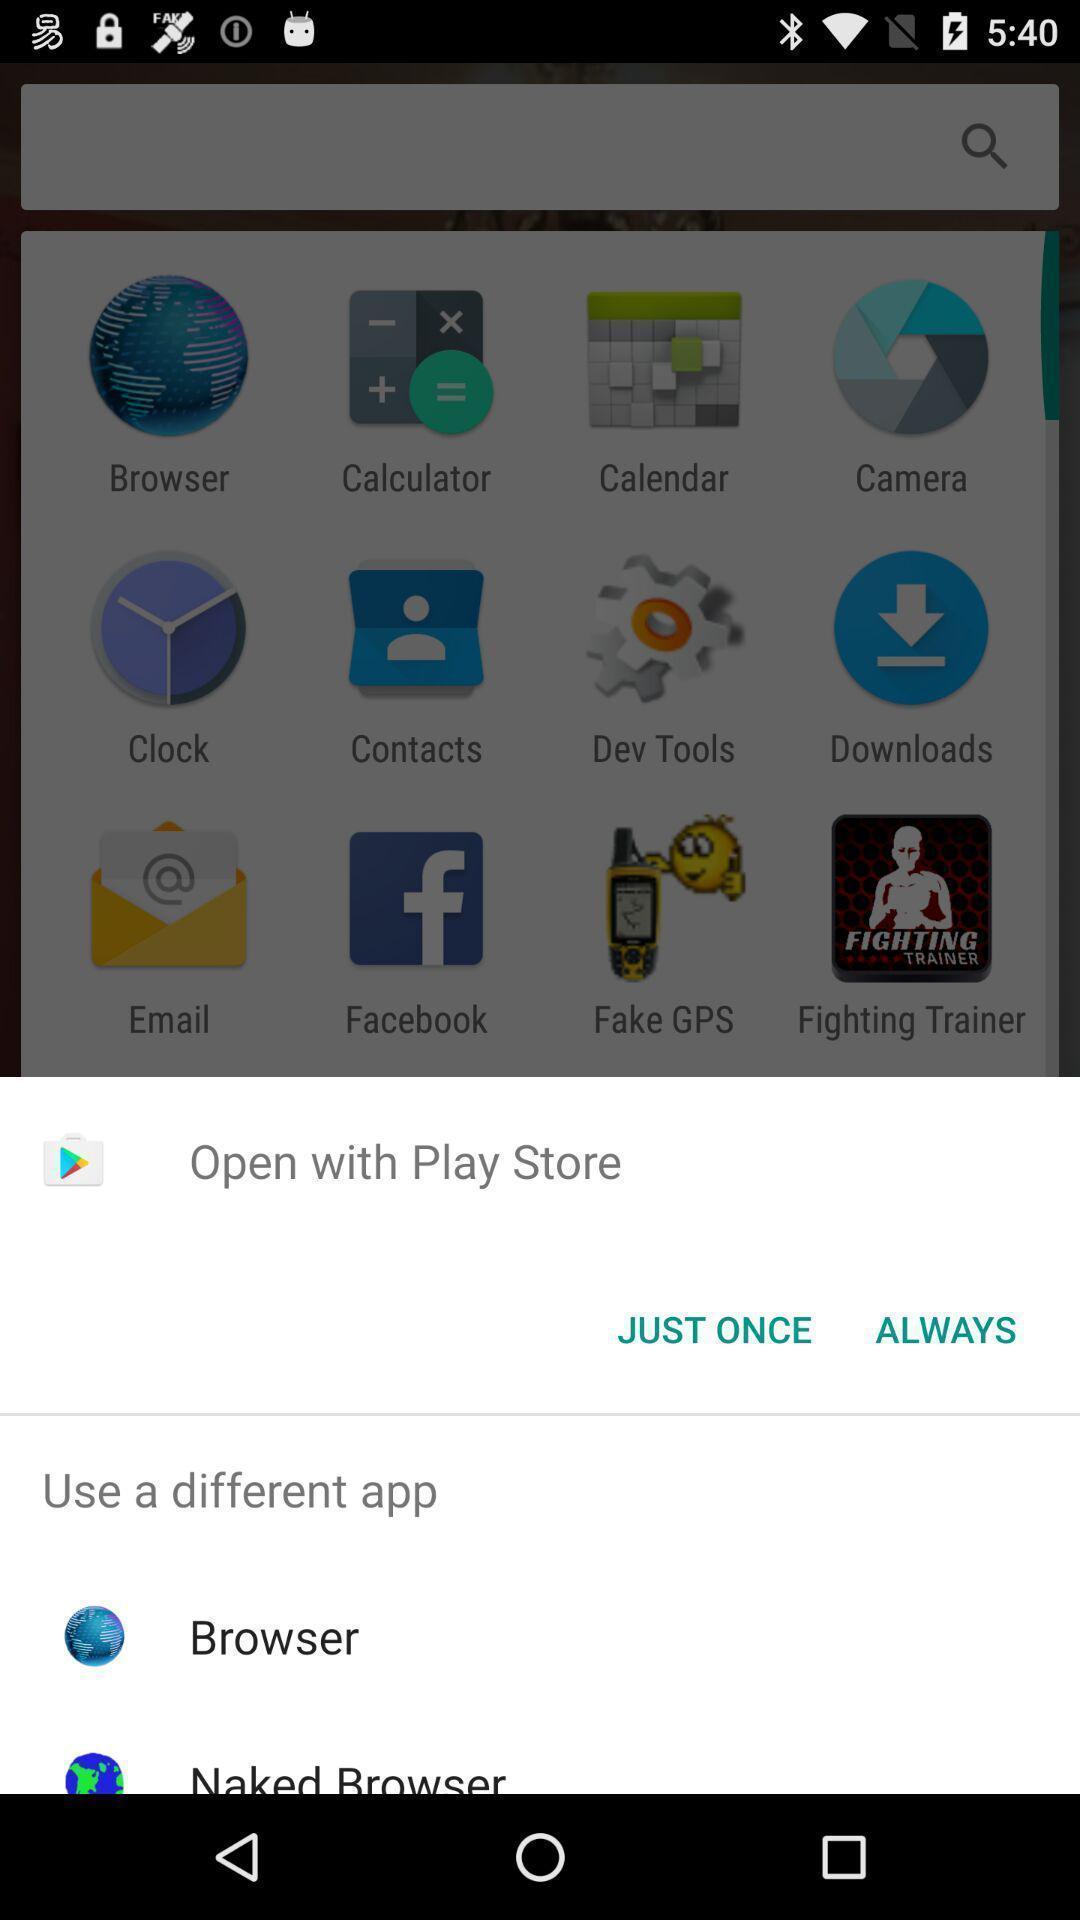Summarize the main components in this picture. Pop-up showing few options. 